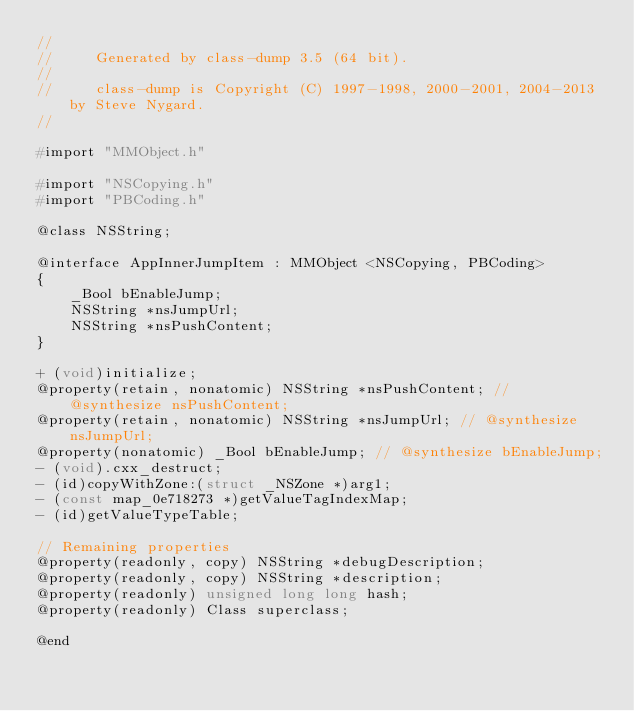Convert code to text. <code><loc_0><loc_0><loc_500><loc_500><_C_>//
//     Generated by class-dump 3.5 (64 bit).
//
//     class-dump is Copyright (C) 1997-1998, 2000-2001, 2004-2013 by Steve Nygard.
//

#import "MMObject.h"

#import "NSCopying.h"
#import "PBCoding.h"

@class NSString;

@interface AppInnerJumpItem : MMObject <NSCopying, PBCoding>
{
    _Bool bEnableJump;
    NSString *nsJumpUrl;
    NSString *nsPushContent;
}

+ (void)initialize;
@property(retain, nonatomic) NSString *nsPushContent; // @synthesize nsPushContent;
@property(retain, nonatomic) NSString *nsJumpUrl; // @synthesize nsJumpUrl;
@property(nonatomic) _Bool bEnableJump; // @synthesize bEnableJump;
- (void).cxx_destruct;
- (id)copyWithZone:(struct _NSZone *)arg1;
- (const map_0e718273 *)getValueTagIndexMap;
- (id)getValueTypeTable;

// Remaining properties
@property(readonly, copy) NSString *debugDescription;
@property(readonly, copy) NSString *description;
@property(readonly) unsigned long long hash;
@property(readonly) Class superclass;

@end

</code> 